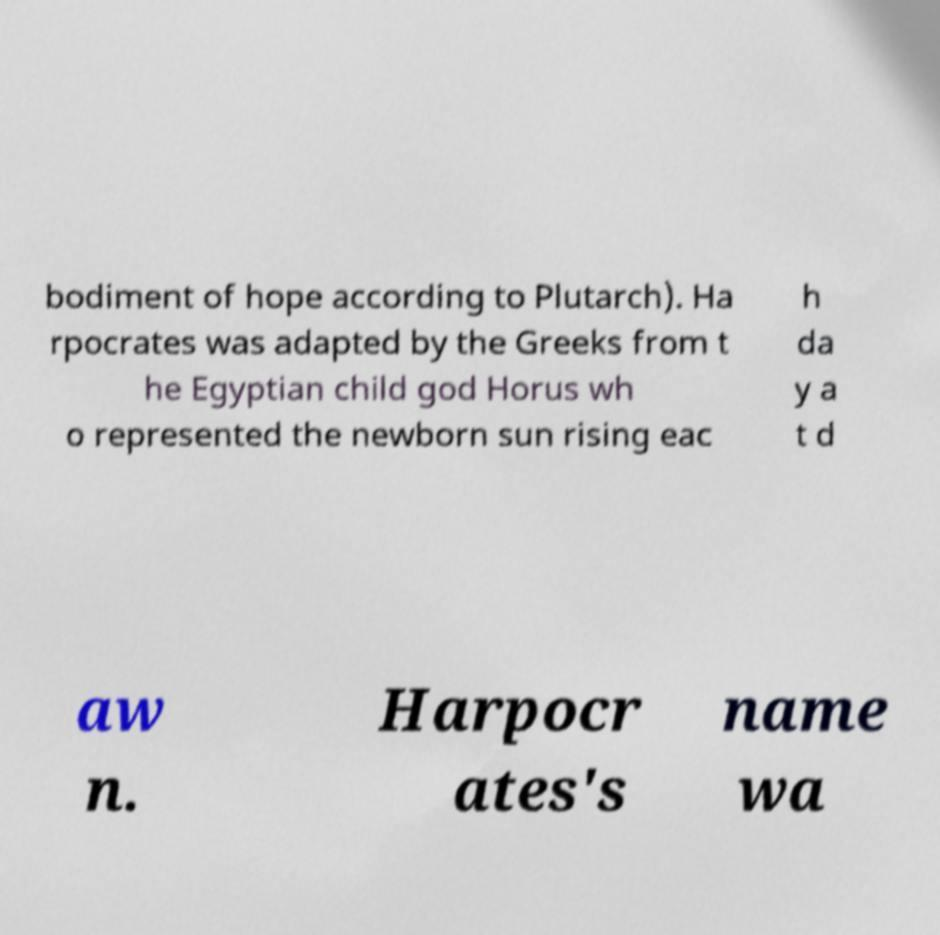Could you extract and type out the text from this image? bodiment of hope according to Plutarch). Ha rpocrates was adapted by the Greeks from t he Egyptian child god Horus wh o represented the newborn sun rising eac h da y a t d aw n. Harpocr ates's name wa 